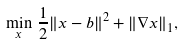Convert formula to latex. <formula><loc_0><loc_0><loc_500><loc_500>\min _ { x } \, \frac { 1 } { 2 } \| x - b \| ^ { 2 } + \| \nabla x \| _ { 1 } ,</formula> 